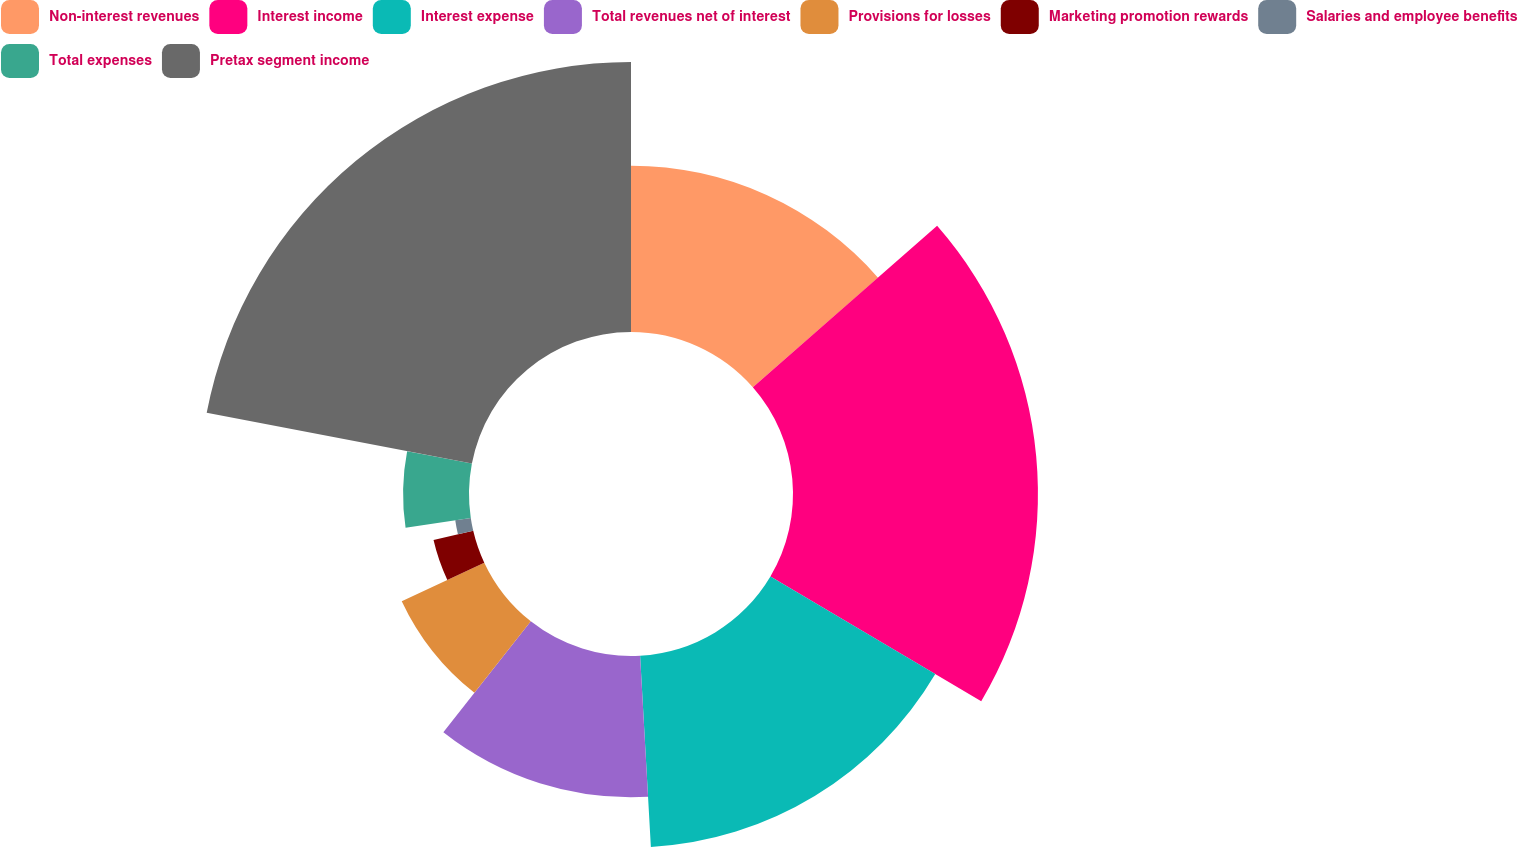Convert chart to OTSL. <chart><loc_0><loc_0><loc_500><loc_500><pie_chart><fcel>Non-interest revenues<fcel>Interest income<fcel>Interest expense<fcel>Total revenues net of interest<fcel>Provisions for losses<fcel>Marketing promotion rewards<fcel>Salaries and employee benefits<fcel>Total expenses<fcel>Pretax segment income<nl><fcel>13.55%<fcel>19.95%<fcel>15.6%<fcel>11.51%<fcel>7.42%<fcel>3.32%<fcel>1.28%<fcel>5.37%<fcel>21.99%<nl></chart> 